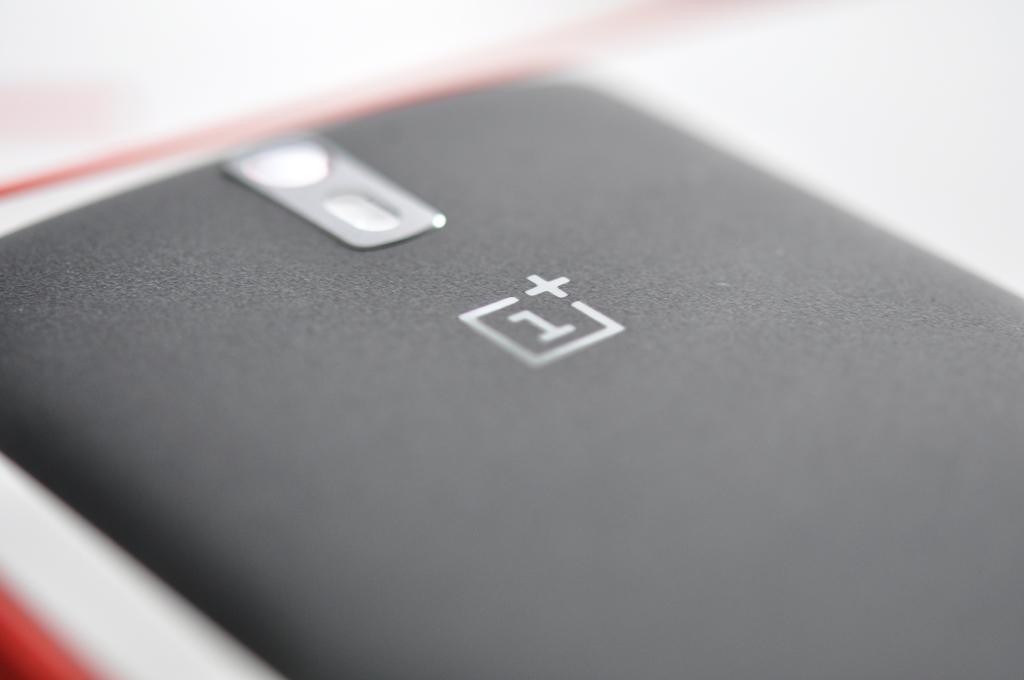What number is before the plus sign on this item?
Your response must be concise. 1. 